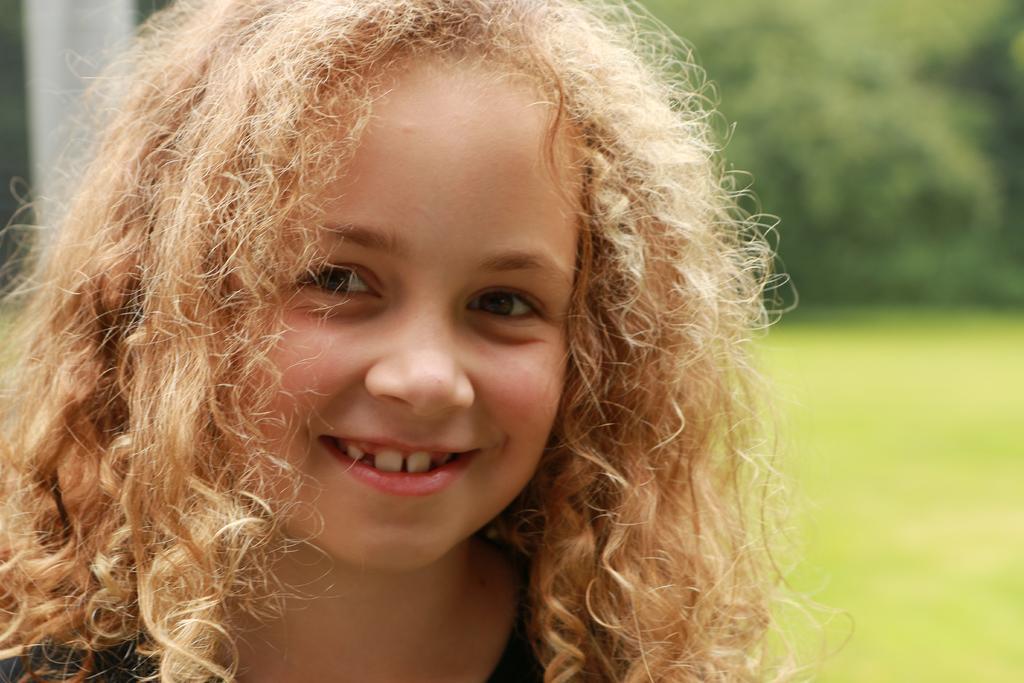Can you describe this image briefly? In this image I can see a girl and I can see smile on her face. In the background I can see green colour and I can see this image is little bit blurry from background. 